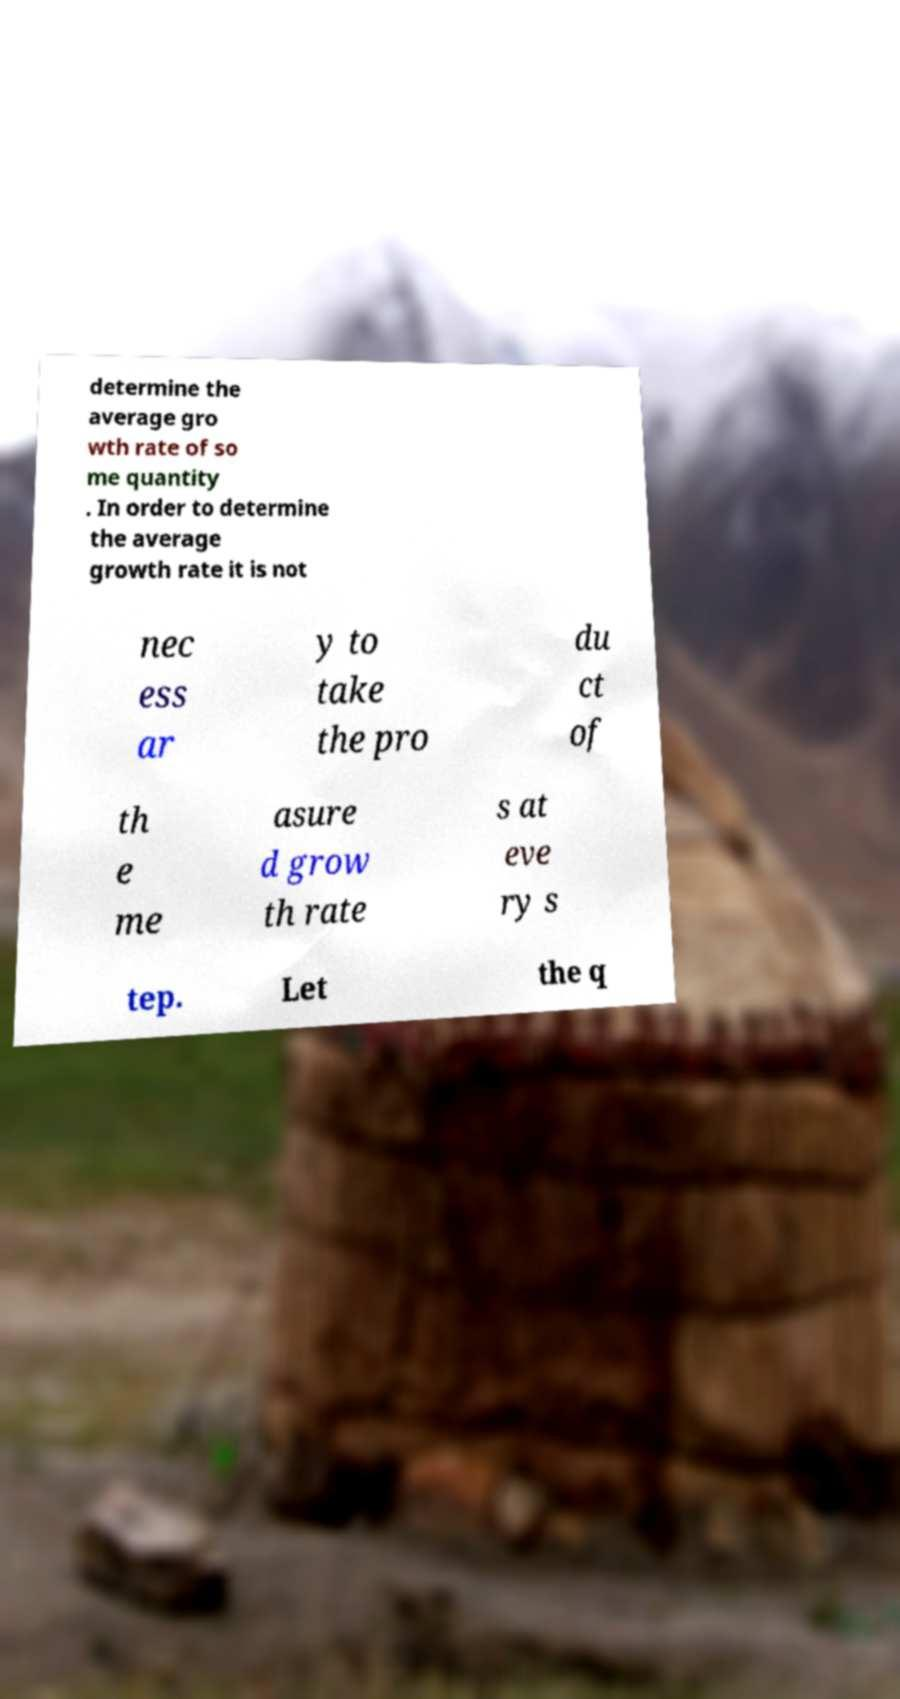Could you assist in decoding the text presented in this image and type it out clearly? determine the average gro wth rate of so me quantity . In order to determine the average growth rate it is not nec ess ar y to take the pro du ct of th e me asure d grow th rate s at eve ry s tep. Let the q 